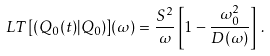Convert formula to latex. <formula><loc_0><loc_0><loc_500><loc_500>L T [ ( Q _ { 0 } ( t ) | Q _ { 0 } ) ] ( \omega ) = \frac { S ^ { 2 } } { \omega } \left [ 1 - \frac { \omega _ { 0 } ^ { 2 } } { D ( \omega ) } \right ] \, .</formula> 